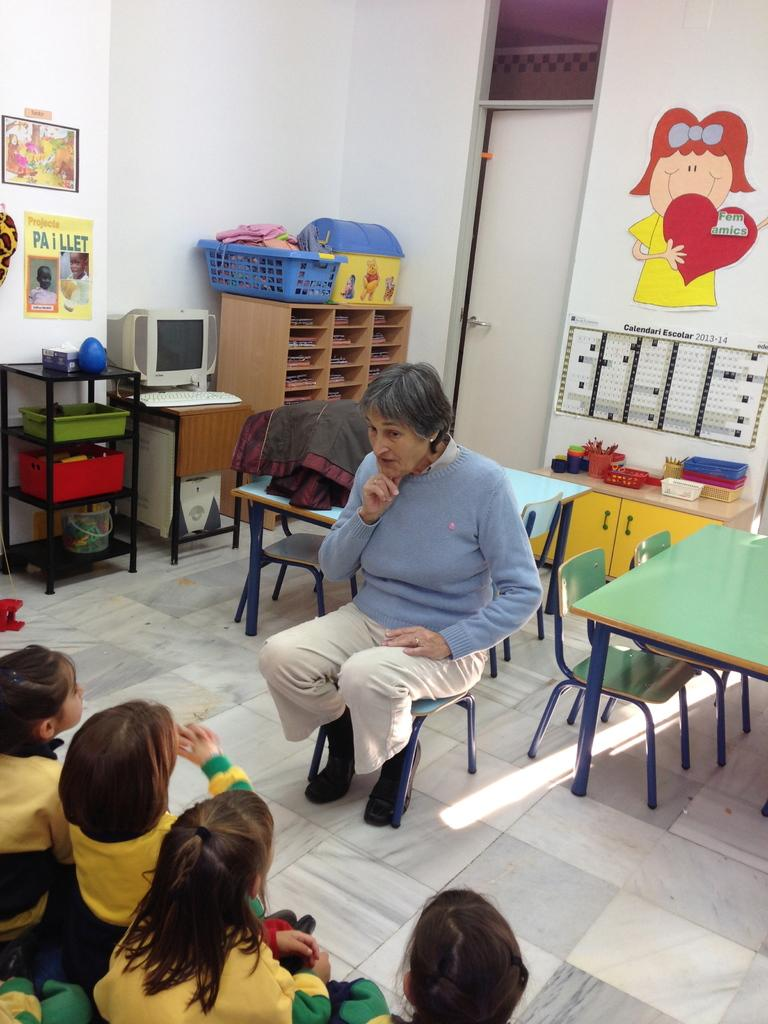<image>
Present a compact description of the photo's key features. A woman in a blue sweater is sitting in front of a clas of children with a drawing of a girl with a heart that reads Fem amics behind her. 